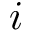Convert formula to latex. <formula><loc_0><loc_0><loc_500><loc_500>i</formula> 